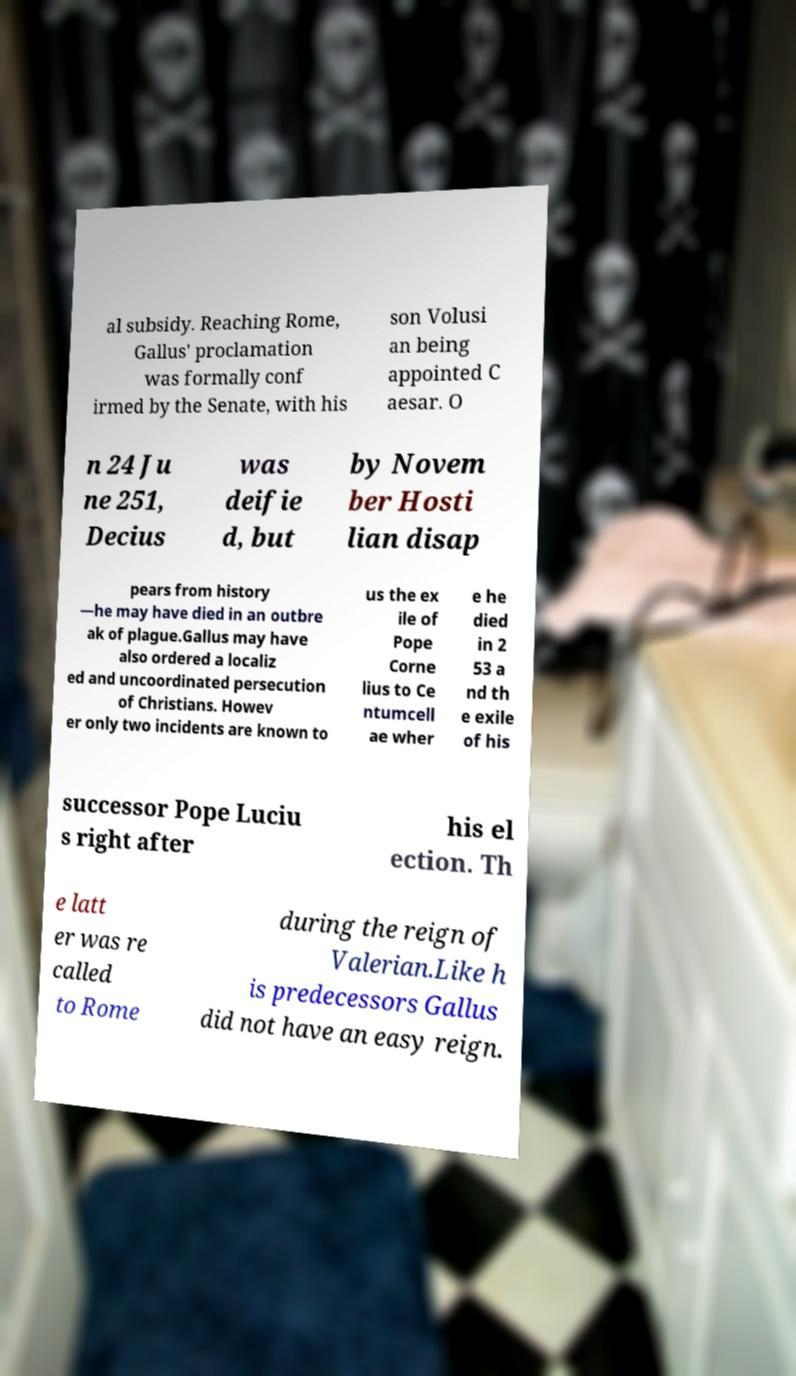Please read and relay the text visible in this image. What does it say? al subsidy. Reaching Rome, Gallus' proclamation was formally conf irmed by the Senate, with his son Volusi an being appointed C aesar. O n 24 Ju ne 251, Decius was deifie d, but by Novem ber Hosti lian disap pears from history —he may have died in an outbre ak of plague.Gallus may have also ordered a localiz ed and uncoordinated persecution of Christians. Howev er only two incidents are known to us the ex ile of Pope Corne lius to Ce ntumcell ae wher e he died in 2 53 a nd th e exile of his successor Pope Luciu s right after his el ection. Th e latt er was re called to Rome during the reign of Valerian.Like h is predecessors Gallus did not have an easy reign. 